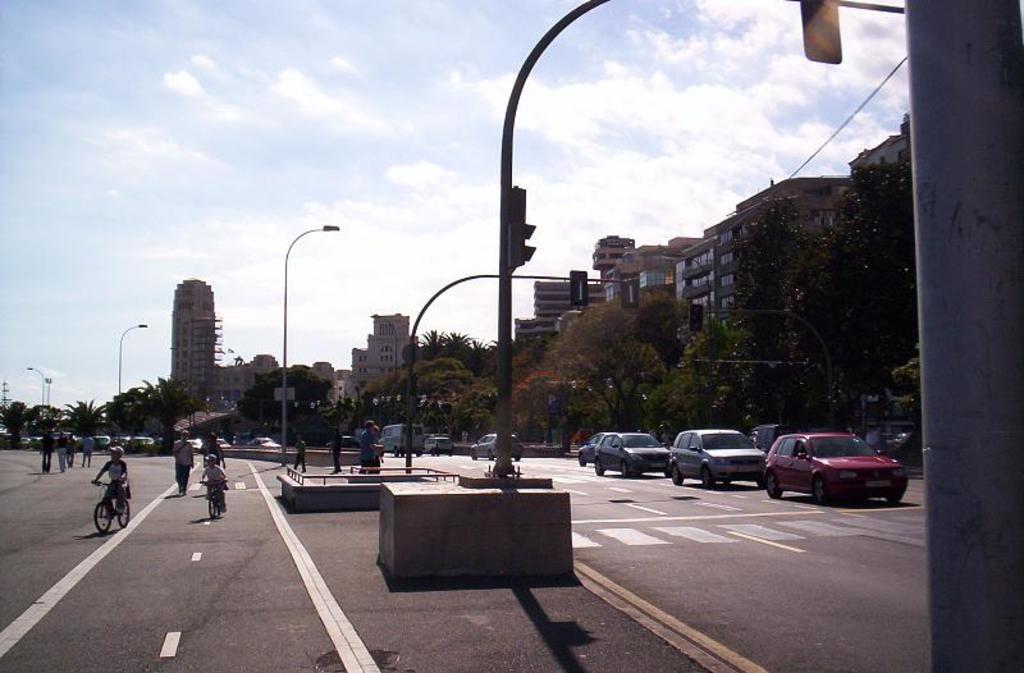In one or two sentences, can you explain what this image depicts? In this picture I can observe some vehicles moving on the road. In the middle of the picture there are poles. In the background there are trees, buildings and clouds in the sky. 